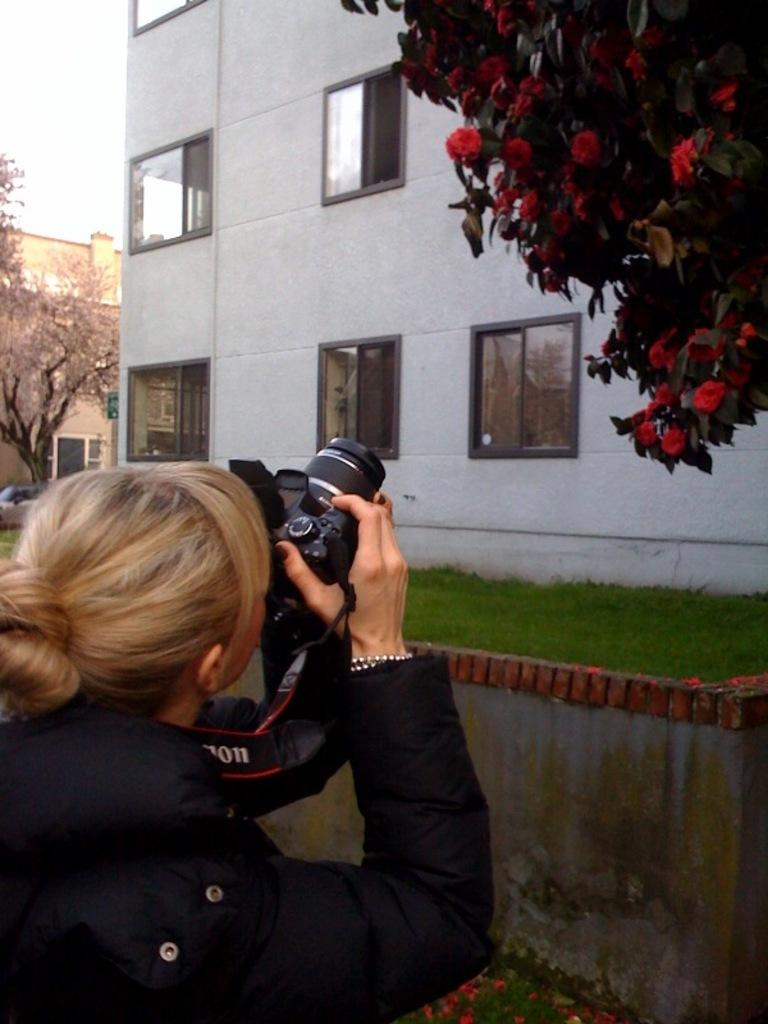Who is the main subject in the image? There is a woman in the image. What is the woman holding in the image? The woman is holding a camera. How many trees can be seen in the image? There are 2 trees in the image. Are there any flowers visible in the image? Yes, flowers are present on one of the trees. What type of structure is in the image? There is a wall in the image. What type of vegetation is visible in the image? Grass is visible in the image. What else can be seen in the background of the image? There are buildings in the image. What type of unit is being used to measure the distance between the trees in the image? There is no unit present in the image, and the distance between the trees is not being measured. 